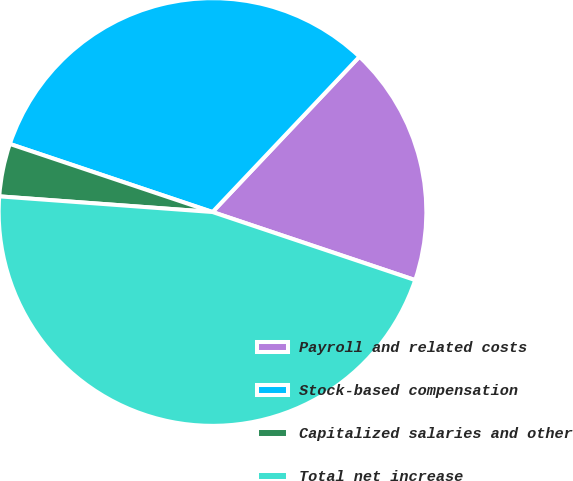<chart> <loc_0><loc_0><loc_500><loc_500><pie_chart><fcel>Payroll and related costs<fcel>Stock-based compensation<fcel>Capitalized salaries and other<fcel>Total net increase<nl><fcel>18.1%<fcel>31.9%<fcel>3.99%<fcel>46.01%<nl></chart> 